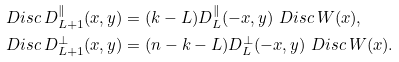<formula> <loc_0><loc_0><loc_500><loc_500>& \ D i s c \, D _ { L + 1 } ^ { \| } ( x , y ) = ( k - L ) D _ { L } ^ { \| } ( - x , y ) \ D i s c \, W ( x ) , \\ & \ D i s c \, D _ { L + 1 } ^ { \perp } ( x , y ) = ( n - k - L ) D _ { L } ^ { \perp } ( - x , y ) \ D i s c \, W ( x ) .</formula> 